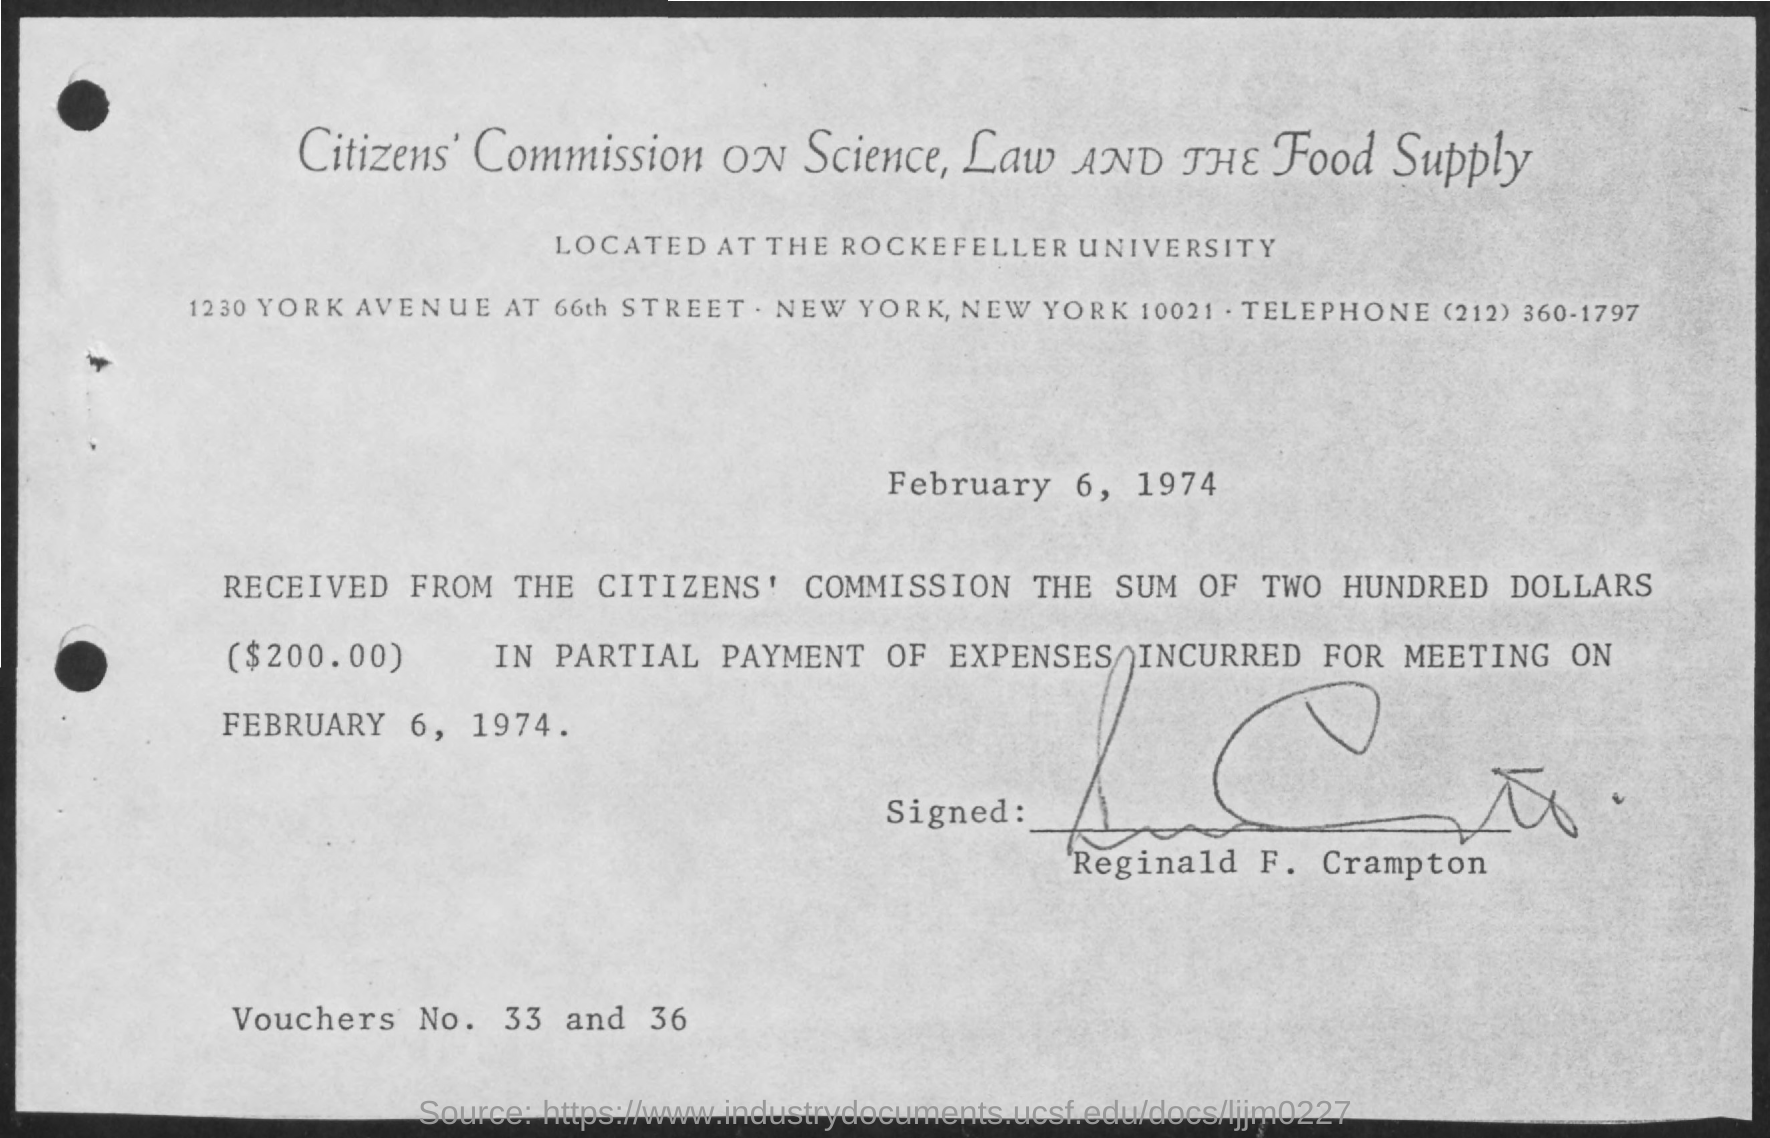List a handful of essential elements in this visual. Thirty-three and thirty-six are the voucher numbers given. The amount received from the Citizen's Commission is $2000.00. The document is dated February 6, 1974. 